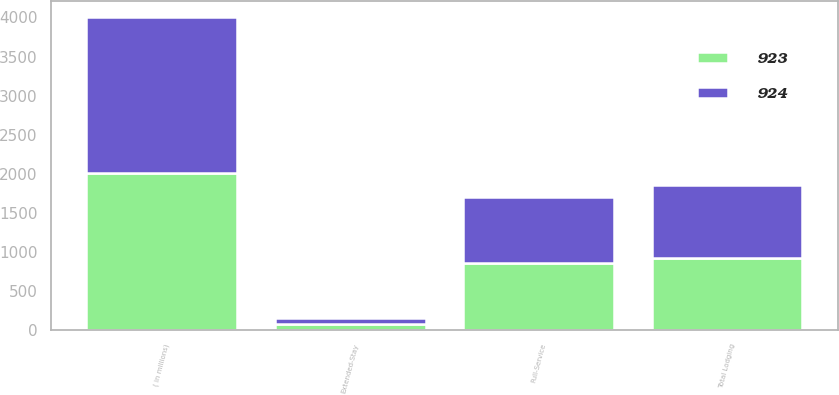<chart> <loc_0><loc_0><loc_500><loc_500><stacked_bar_chart><ecel><fcel>( in millions)<fcel>Full-Service<fcel>Extended-Stay<fcel>Total Lodging<nl><fcel>924<fcel>2005<fcel>852<fcel>72<fcel>924<nl><fcel>923<fcel>2004<fcel>851<fcel>72<fcel>923<nl></chart> 